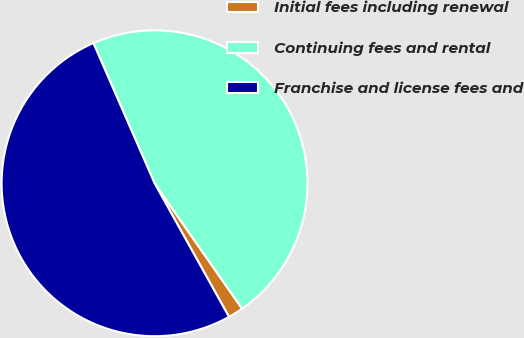Convert chart to OTSL. <chart><loc_0><loc_0><loc_500><loc_500><pie_chart><fcel>Initial fees including renewal<fcel>Continuing fees and rental<fcel>Franchise and license fees and<nl><fcel>1.61%<fcel>46.85%<fcel>51.54%<nl></chart> 